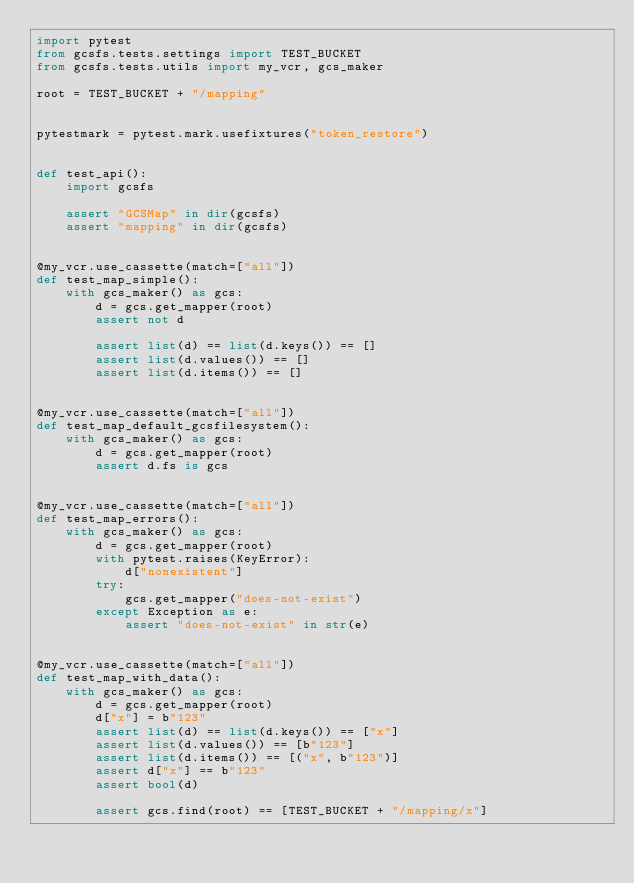Convert code to text. <code><loc_0><loc_0><loc_500><loc_500><_Python_>import pytest
from gcsfs.tests.settings import TEST_BUCKET
from gcsfs.tests.utils import my_vcr, gcs_maker

root = TEST_BUCKET + "/mapping"


pytestmark = pytest.mark.usefixtures("token_restore")


def test_api():
    import gcsfs

    assert "GCSMap" in dir(gcsfs)
    assert "mapping" in dir(gcsfs)


@my_vcr.use_cassette(match=["all"])
def test_map_simple():
    with gcs_maker() as gcs:
        d = gcs.get_mapper(root)
        assert not d

        assert list(d) == list(d.keys()) == []
        assert list(d.values()) == []
        assert list(d.items()) == []


@my_vcr.use_cassette(match=["all"])
def test_map_default_gcsfilesystem():
    with gcs_maker() as gcs:
        d = gcs.get_mapper(root)
        assert d.fs is gcs


@my_vcr.use_cassette(match=["all"])
def test_map_errors():
    with gcs_maker() as gcs:
        d = gcs.get_mapper(root)
        with pytest.raises(KeyError):
            d["nonexistent"]
        try:
            gcs.get_mapper("does-not-exist")
        except Exception as e:
            assert "does-not-exist" in str(e)


@my_vcr.use_cassette(match=["all"])
def test_map_with_data():
    with gcs_maker() as gcs:
        d = gcs.get_mapper(root)
        d["x"] = b"123"
        assert list(d) == list(d.keys()) == ["x"]
        assert list(d.values()) == [b"123"]
        assert list(d.items()) == [("x", b"123")]
        assert d["x"] == b"123"
        assert bool(d)

        assert gcs.find(root) == [TEST_BUCKET + "/mapping/x"]</code> 